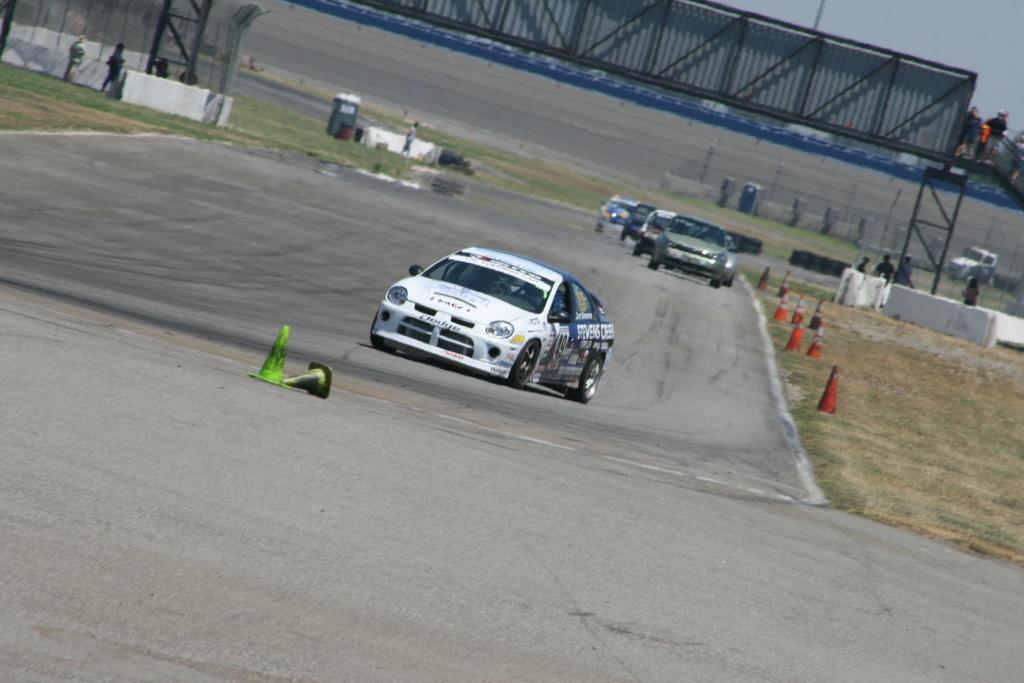Who or what can be seen in the image? There are people in the image. What objects are present on the road in the image? There are cards on the road in the image. What safety equipment is visible in the image? There are traffic cones in the image. What structures can be seen in the image? There is a railing and a wall in the image. What part of the natural environment is visible in the image? The sky is visible in the image. What type of knee injury is being treated at the party in the image? There is no party or knee injury present in the image. What rule is being enforced by the person holding the cards in the image? There is no person holding cards in the image, and therefore no rule enforcement can be observed. 